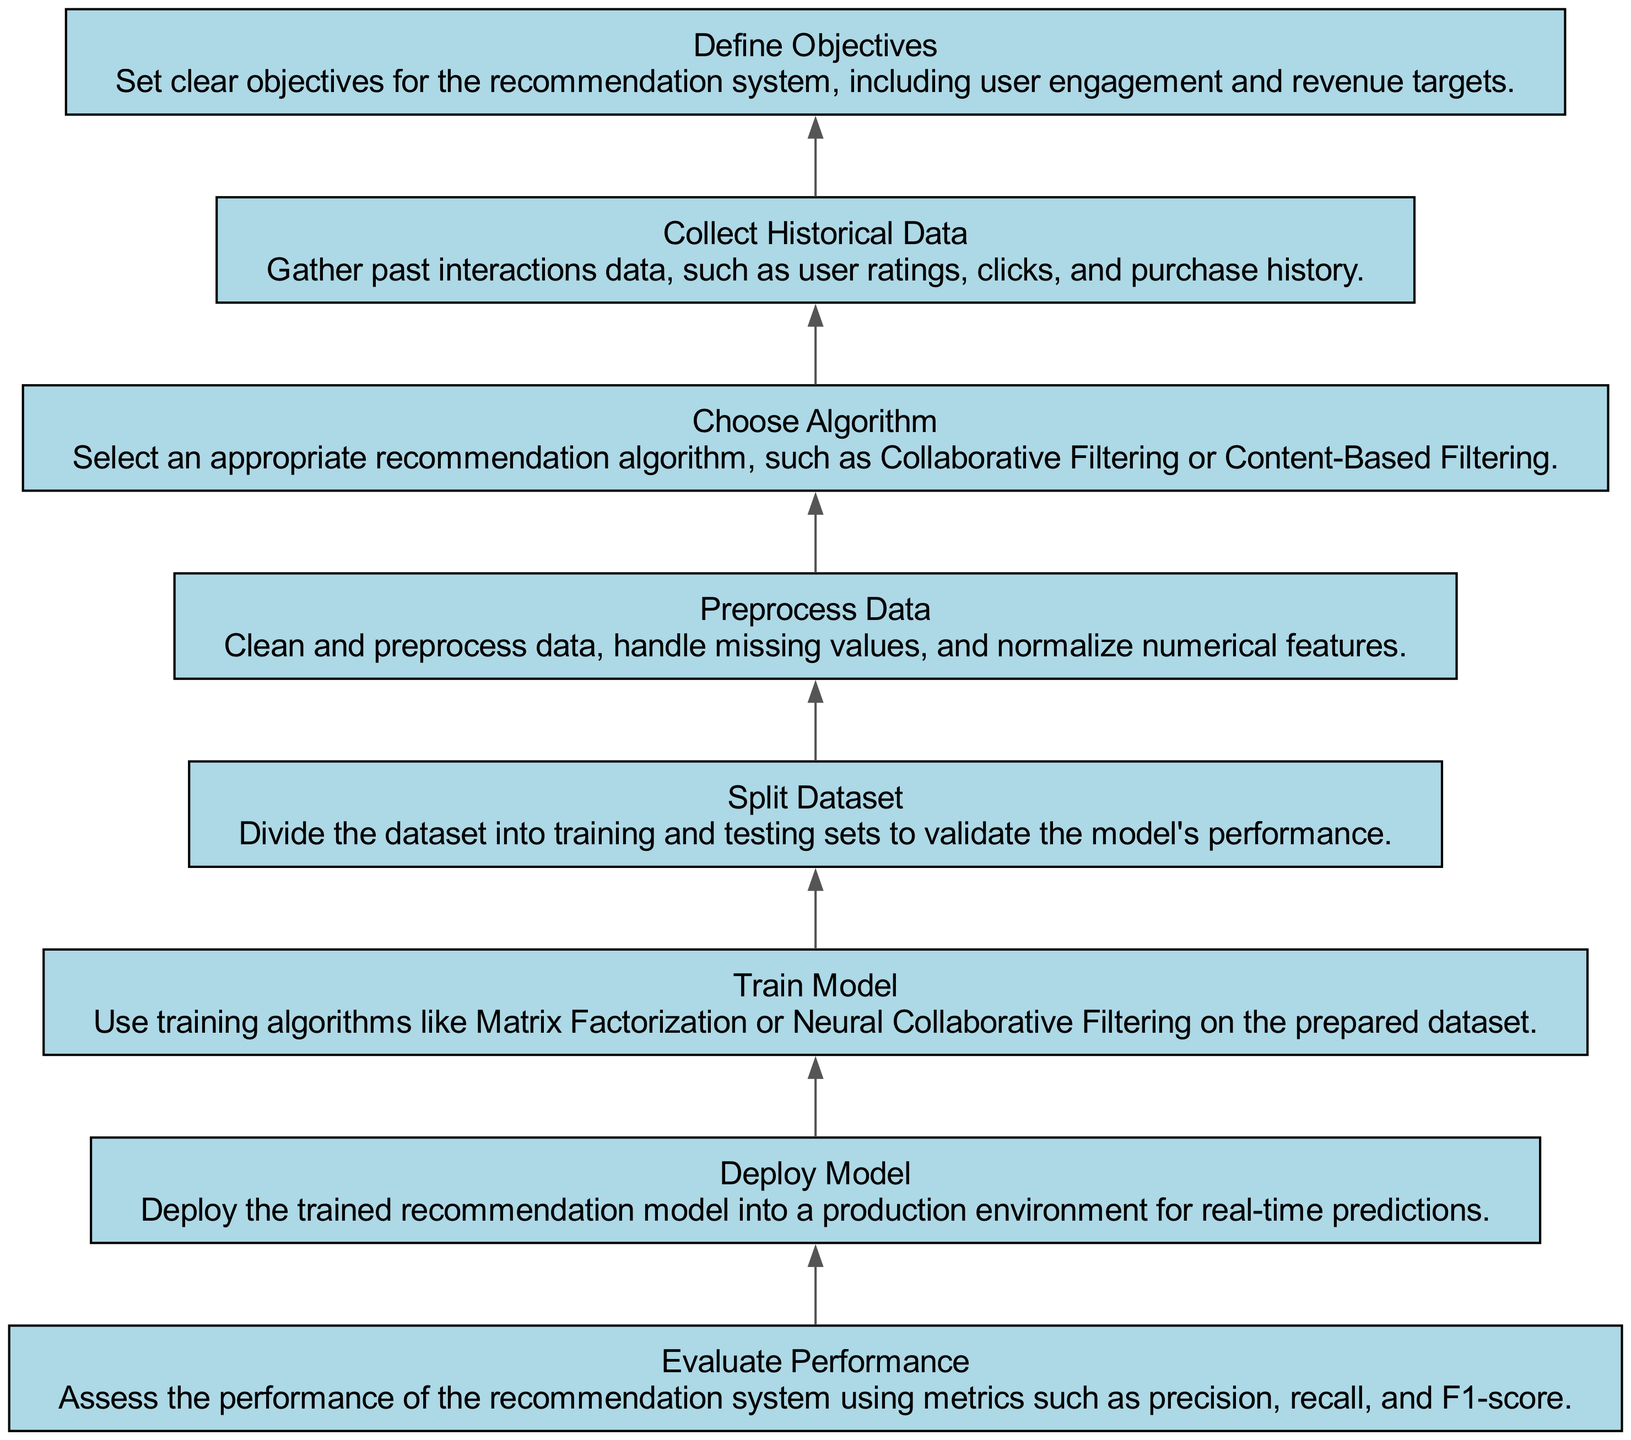What is the first step in the diagram? The first step in the diagram is "Define Objectives", which is the lowest node in the flowchart. It determines the goals for the recommendation system, setting a foundation for subsequent steps.
Answer: Define Objectives How many total nodes are in the diagram? By counting each unique process listed in the flowchart from bottom to top, we find that there are 8 distinct nodes shown in the diagram.
Answer: 8 Which step follows "Collect Historical Data"? The step that follows "Collect Historical Data" is "Choose Algorithm", indicating the next action taken after gathering past interactions.
Answer: Choose Algorithm What metrics are used to assess performance? The diagram mentions metrics such as precision, recall, and F1-score in the "Evaluate Performance" step, clarifying the criteria for evaluation.
Answer: Precision, recall, F1-score Which two processes directly precede "Deploy Model"? The two processes that directly precede "Deploy Model" are "Train Model" and "Evaluate Performance", indicating that the model must first be trained and evaluated before deployment.
Answer: Train Model, Evaluate Performance Is "Split Dataset" above "Preprocess Data"? In the flowchart, "Split Dataset" is positioned above "Preprocess Data", suggesting that the dataset is first divided into training and testing sets and then preprocessed.
Answer: Yes What is the main objective of the recommendation system as defined in the diagram? The main objective, as indicated in the "Define Objectives" step, is to achieve user engagement and revenue targets, showcasing the focus of the recommendation system.
Answer: User engagement, revenue targets What is the last step shown in the diagram? The last step shown in the diagram is "Deploy Model", which indicates that after training and evaluating, the model is taken into operation for real-time predictions.
Answer: Deploy Model 